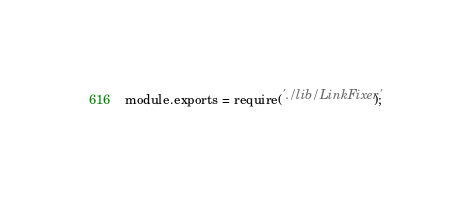Convert code to text. <code><loc_0><loc_0><loc_500><loc_500><_JavaScript_>module.exports = require('./lib/LinkFixer');
</code> 